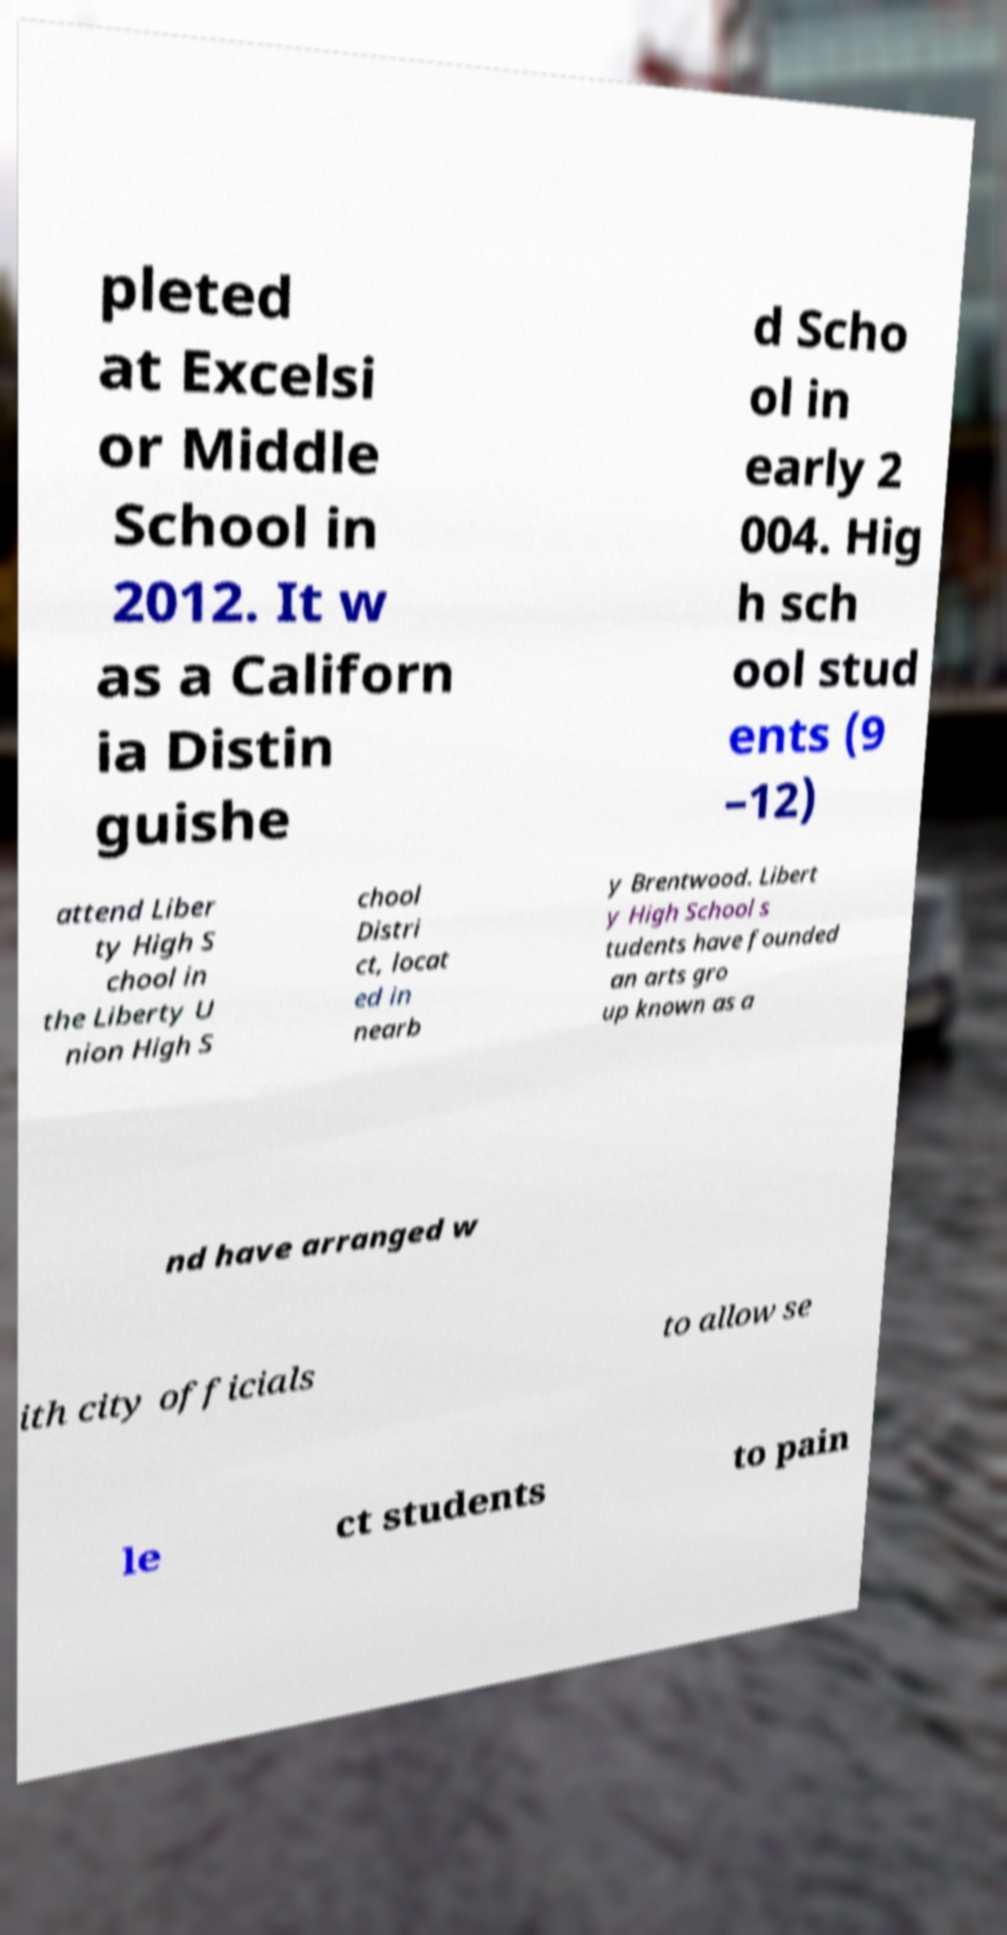Can you read and provide the text displayed in the image?This photo seems to have some interesting text. Can you extract and type it out for me? pleted at Excelsi or Middle School in 2012. It w as a Californ ia Distin guishe d Scho ol in early 2 004. Hig h sch ool stud ents (9 –12) attend Liber ty High S chool in the Liberty U nion High S chool Distri ct, locat ed in nearb y Brentwood. Libert y High School s tudents have founded an arts gro up known as a nd have arranged w ith city officials to allow se le ct students to pain 